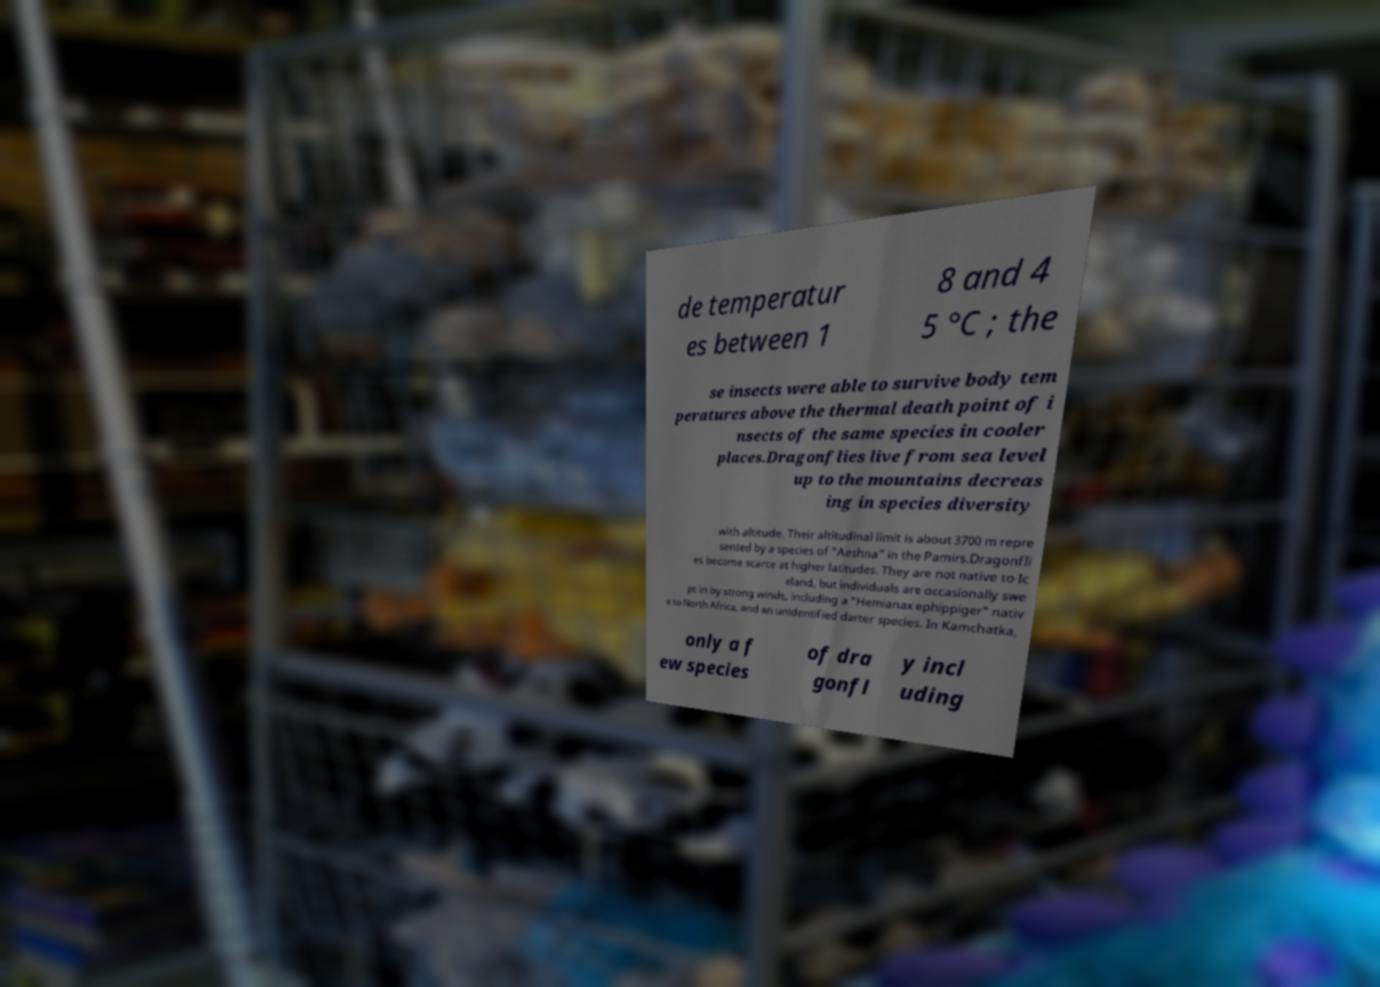For documentation purposes, I need the text within this image transcribed. Could you provide that? de temperatur es between 1 8 and 4 5 °C ; the se insects were able to survive body tem peratures above the thermal death point of i nsects of the same species in cooler places.Dragonflies live from sea level up to the mountains decreas ing in species diversity with altitude. Their altitudinal limit is about 3700 m repre sented by a species of "Aeshna" in the Pamirs.Dragonfli es become scarce at higher latitudes. They are not native to Ic eland, but individuals are occasionally swe pt in by strong winds, including a "Hemianax ephippiger" nativ e to North Africa, and an unidentified darter species. In Kamchatka, only a f ew species of dra gonfl y incl uding 